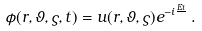Convert formula to latex. <formula><loc_0><loc_0><loc_500><loc_500>\phi ( { r } , \vartheta , \varsigma , t ) = u ( { r } , \vartheta , \varsigma ) e ^ { - i \frac { E t } { } } \, .</formula> 